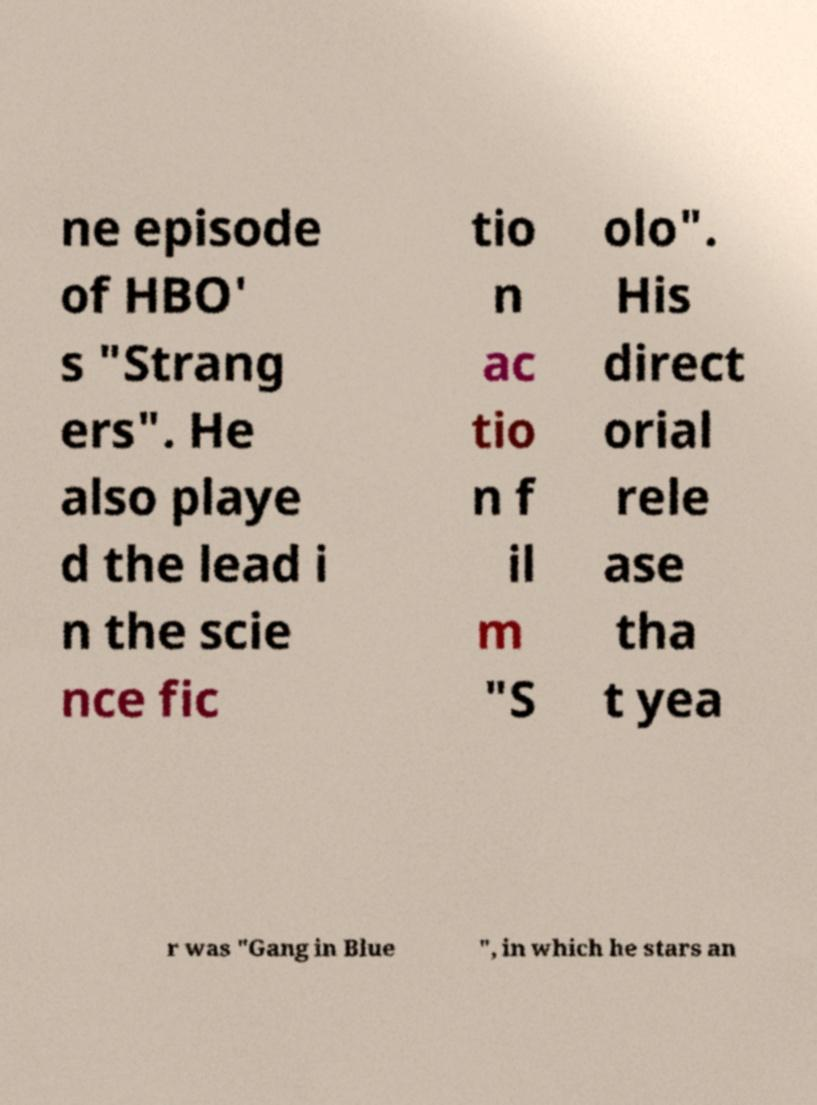Please identify and transcribe the text found in this image. ne episode of HBO' s "Strang ers". He also playe d the lead i n the scie nce fic tio n ac tio n f il m "S olo". His direct orial rele ase tha t yea r was "Gang in Blue ", in which he stars an 